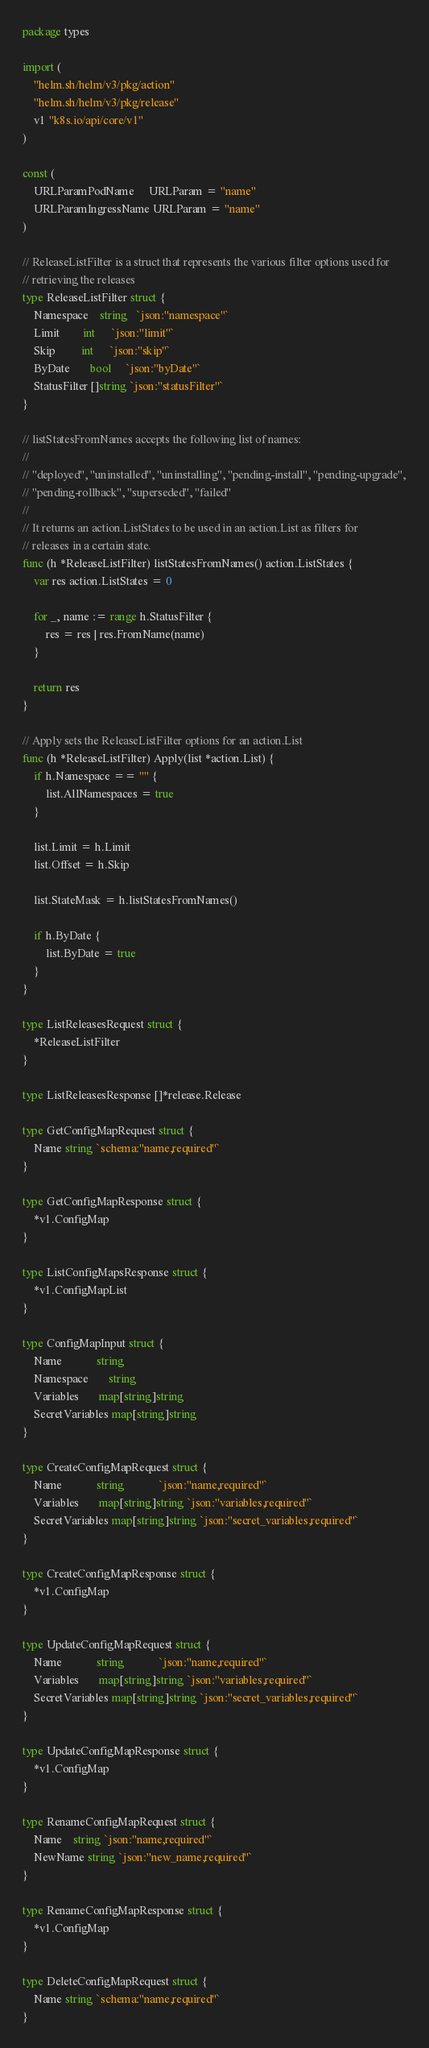Convert code to text. <code><loc_0><loc_0><loc_500><loc_500><_Go_>package types

import (
	"helm.sh/helm/v3/pkg/action"
	"helm.sh/helm/v3/pkg/release"
	v1 "k8s.io/api/core/v1"
)

const (
	URLParamPodName     URLParam = "name"
	URLParamIngressName URLParam = "name"
)

// ReleaseListFilter is a struct that represents the various filter options used for
// retrieving the releases
type ReleaseListFilter struct {
	Namespace    string   `json:"namespace"`
	Limit        int      `json:"limit"`
	Skip         int      `json:"skip"`
	ByDate       bool     `json:"byDate"`
	StatusFilter []string `json:"statusFilter"`
}

// listStatesFromNames accepts the following list of names:
//
// "deployed", "uninstalled", "uninstalling", "pending-install", "pending-upgrade",
// "pending-rollback", "superseded", "failed"
//
// It returns an action.ListStates to be used in an action.List as filters for
// releases in a certain state.
func (h *ReleaseListFilter) listStatesFromNames() action.ListStates {
	var res action.ListStates = 0

	for _, name := range h.StatusFilter {
		res = res | res.FromName(name)
	}

	return res
}

// Apply sets the ReleaseListFilter options for an action.List
func (h *ReleaseListFilter) Apply(list *action.List) {
	if h.Namespace == "" {
		list.AllNamespaces = true
	}

	list.Limit = h.Limit
	list.Offset = h.Skip

	list.StateMask = h.listStatesFromNames()

	if h.ByDate {
		list.ByDate = true
	}
}

type ListReleasesRequest struct {
	*ReleaseListFilter
}

type ListReleasesResponse []*release.Release

type GetConfigMapRequest struct {
	Name string `schema:"name,required"`
}

type GetConfigMapResponse struct {
	*v1.ConfigMap
}

type ListConfigMapsResponse struct {
	*v1.ConfigMapList
}

type ConfigMapInput struct {
	Name            string
	Namespace       string
	Variables       map[string]string
	SecretVariables map[string]string
}

type CreateConfigMapRequest struct {
	Name            string            `json:"name,required"`
	Variables       map[string]string `json:"variables,required"`
	SecretVariables map[string]string `json:"secret_variables,required"`
}

type CreateConfigMapResponse struct {
	*v1.ConfigMap
}

type UpdateConfigMapRequest struct {
	Name            string            `json:"name,required"`
	Variables       map[string]string `json:"variables,required"`
	SecretVariables map[string]string `json:"secret_variables,required"`
}

type UpdateConfigMapResponse struct {
	*v1.ConfigMap
}

type RenameConfigMapRequest struct {
	Name    string `json:"name,required"`
	NewName string `json:"new_name,required"`
}

type RenameConfigMapResponse struct {
	*v1.ConfigMap
}

type DeleteConfigMapRequest struct {
	Name string `schema:"name,required"`
}
</code> 